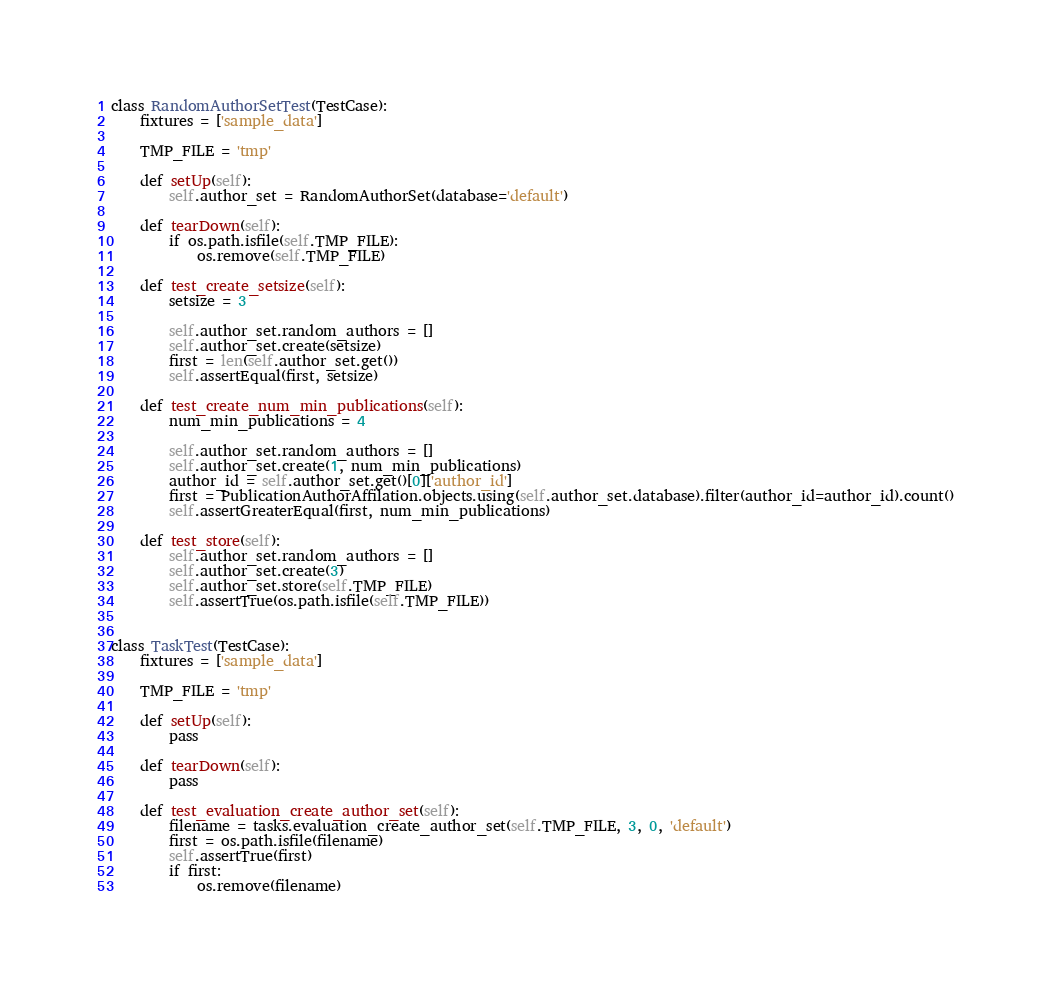<code> <loc_0><loc_0><loc_500><loc_500><_Python_>class RandomAuthorSetTest(TestCase):
    fixtures = ['sample_data']

    TMP_FILE = 'tmp'

    def setUp(self):
        self.author_set = RandomAuthorSet(database='default')
        
    def tearDown(self):
        if os.path.isfile(self.TMP_FILE):
            os.remove(self.TMP_FILE)
     
    def test_create_setsize(self):
        setsize = 3
        
        self.author_set.random_authors = []
        self.author_set.create(setsize)     
        first = len(self.author_set.get())
        self.assertEqual(first, setsize)

    def test_create_num_min_publications(self):
        num_min_publications = 4
        
        self.author_set.random_authors = []
        self.author_set.create(1, num_min_publications)
        author_id = self.author_set.get()[0]['author_id']
        first = PublicationAuthorAffilation.objects.using(self.author_set.database).filter(author_id=author_id).count()
        self.assertGreaterEqual(first, num_min_publications)
 
    def test_store(self):
        self.author_set.random_authors = []
        self.author_set.create(3)
        self.author_set.store(self.TMP_FILE)
        self.assertTrue(os.path.isfile(self.TMP_FILE))


class TaskTest(TestCase):
    fixtures = ['sample_data']

    TMP_FILE = 'tmp'

    def setUp(self):
        pass
    
    def tearDown(self):
        pass
     
    def test_evaluation_create_author_set(self):
        filename = tasks.evaluation_create_author_set(self.TMP_FILE, 3, 0, 'default')
        first = os.path.isfile(filename)
        self.assertTrue(first)
        if first:
            os.remove(filename)
</code> 